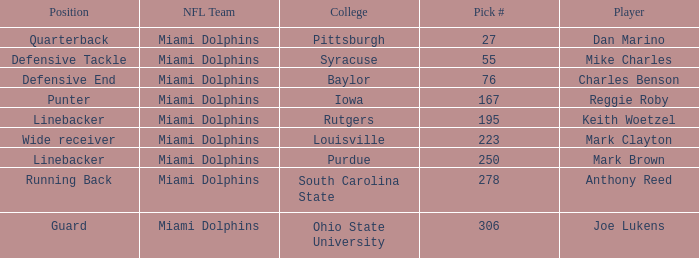Which Position has a Pick # lower than 278 for Player Charles Benson? Defensive End. 